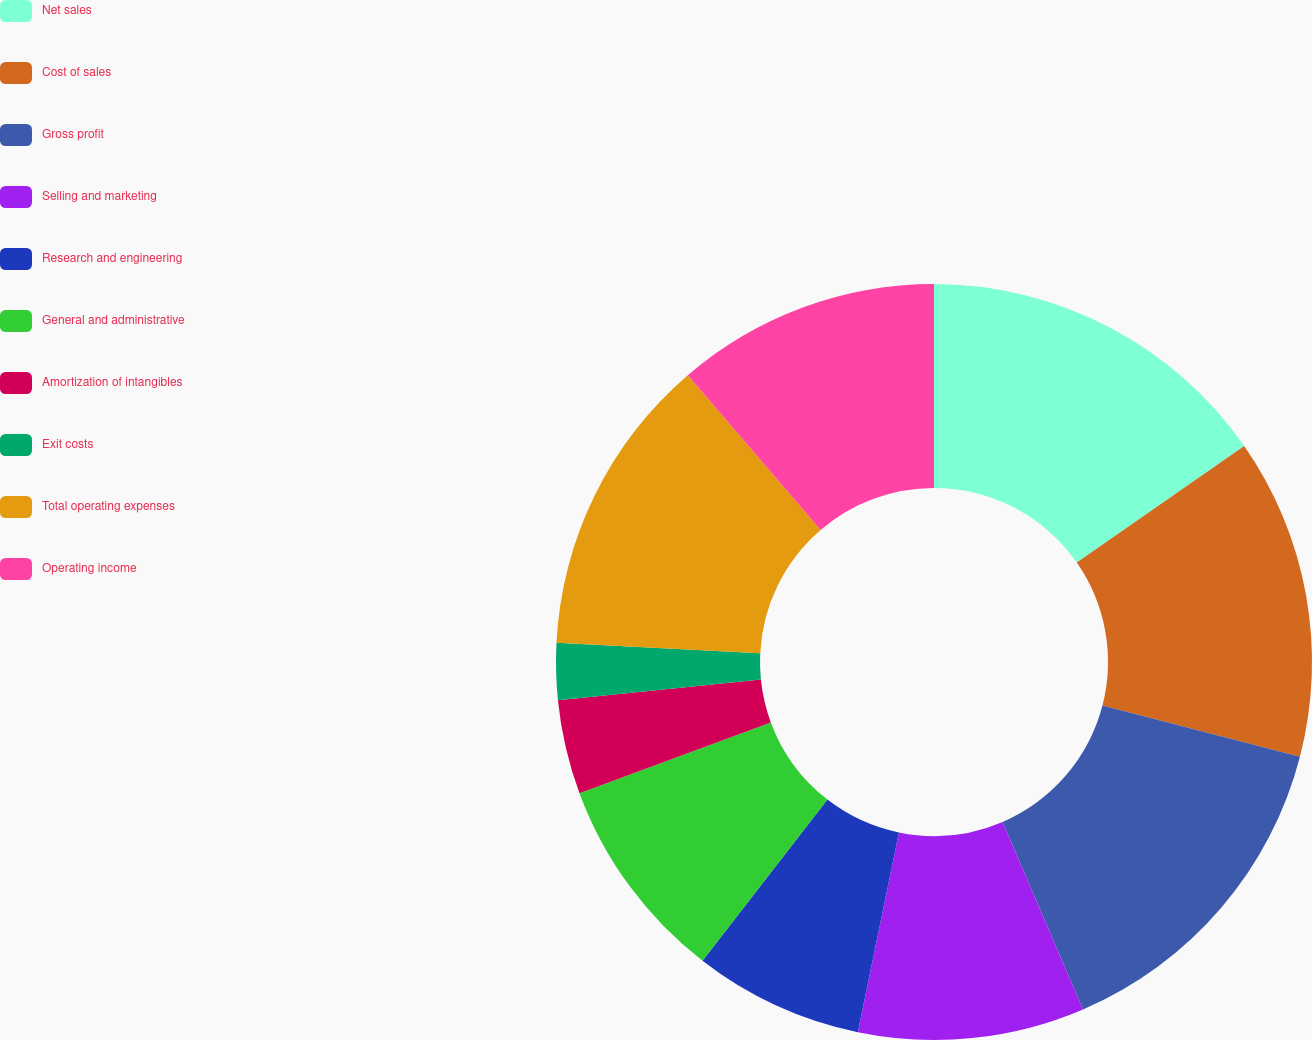Convert chart. <chart><loc_0><loc_0><loc_500><loc_500><pie_chart><fcel>Net sales<fcel>Cost of sales<fcel>Gross profit<fcel>Selling and marketing<fcel>Research and engineering<fcel>General and administrative<fcel>Amortization of intangibles<fcel>Exit costs<fcel>Total operating expenses<fcel>Operating income<nl><fcel>15.32%<fcel>13.71%<fcel>14.52%<fcel>9.68%<fcel>7.26%<fcel>8.87%<fcel>4.03%<fcel>2.42%<fcel>12.9%<fcel>11.29%<nl></chart> 